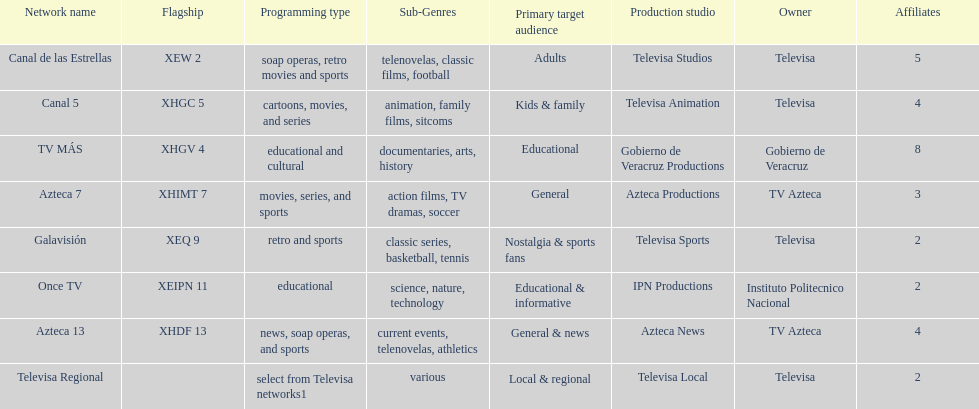Which owner has the most networks? Televisa. 